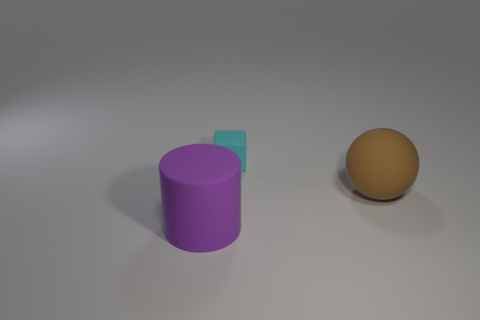What is the size of the rubber object that is both to the left of the brown object and in front of the cyan block?
Your response must be concise. Large. What is the size of the object that is on the right side of the matte object that is behind the large matte object behind the big purple cylinder?
Keep it short and to the point. Large. What number of other objects are there of the same color as the cube?
Offer a terse response. 0. There is a big object in front of the brown matte thing; is its color the same as the small block?
Provide a short and direct response. No. How many objects are either big cylinders or cyan rubber blocks?
Your answer should be compact. 2. There is a big rubber object that is on the right side of the large cylinder; what is its color?
Make the answer very short. Brown. Is the number of small cyan blocks that are in front of the rubber block less than the number of small red matte blocks?
Your answer should be very brief. No. Is there anything else that is the same size as the cyan block?
Your answer should be compact. No. Is the brown ball made of the same material as the tiny cyan object?
Give a very brief answer. Yes. What number of things are either tiny rubber objects that are behind the large purple thing or big rubber objects that are in front of the large brown thing?
Offer a very short reply. 2. 